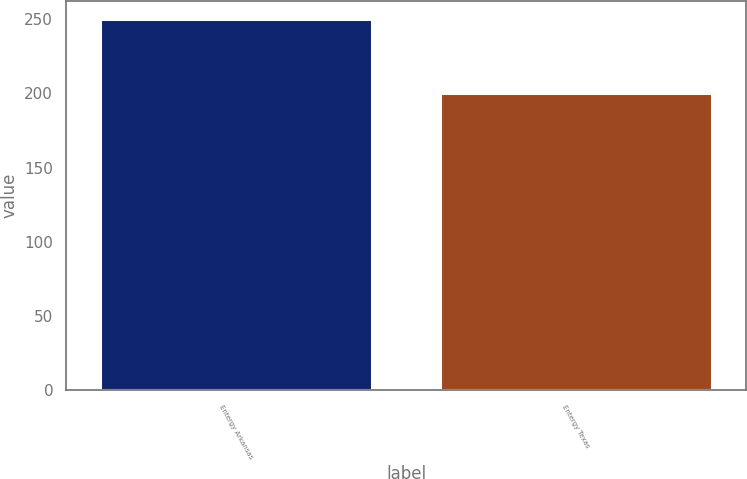<chart> <loc_0><loc_0><loc_500><loc_500><bar_chart><fcel>Entergy Arkansas<fcel>Entergy Texas<nl><fcel>250<fcel>200<nl></chart> 